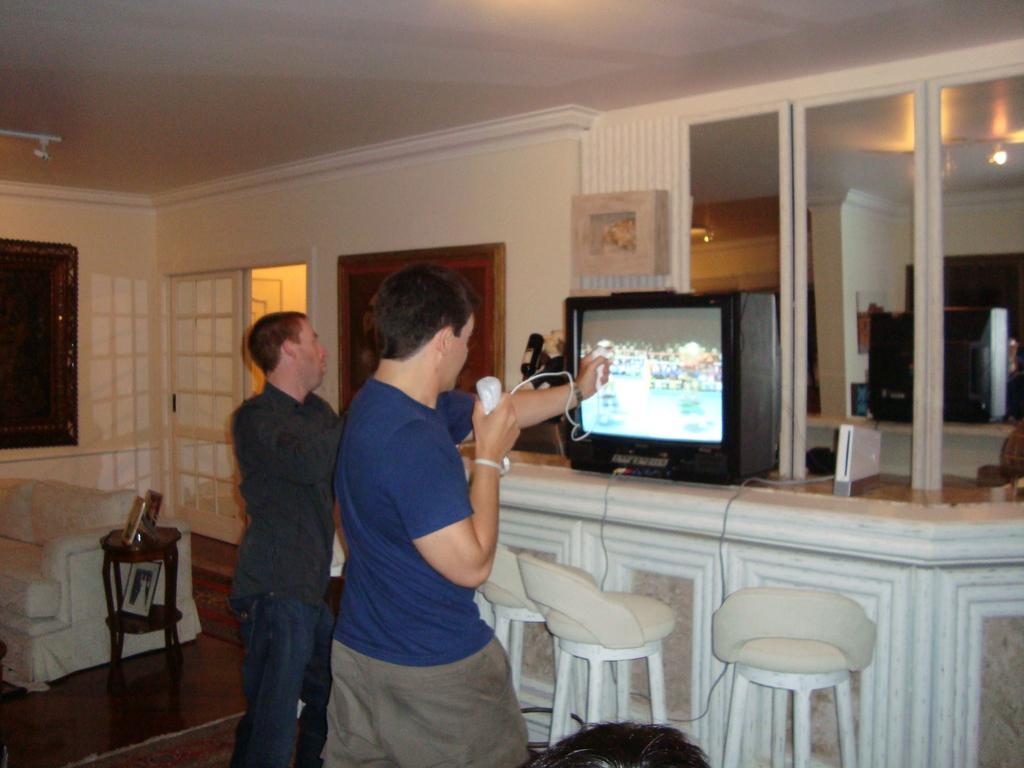In one or two sentences, can you explain what this image depicts? There are two men standing and this man holding object. We can see chairs and sofa. We can see television and objects on shelf and we can see frames on the wall and we can see glass,through this glass we can see television and lights. 